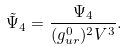Convert formula to latex. <formula><loc_0><loc_0><loc_500><loc_500>\tilde { \Psi } _ { 4 } = \frac { \Psi _ { 4 } } { ( g _ { u r } ^ { 0 } ) ^ { 2 } V ^ { 3 } } .</formula> 